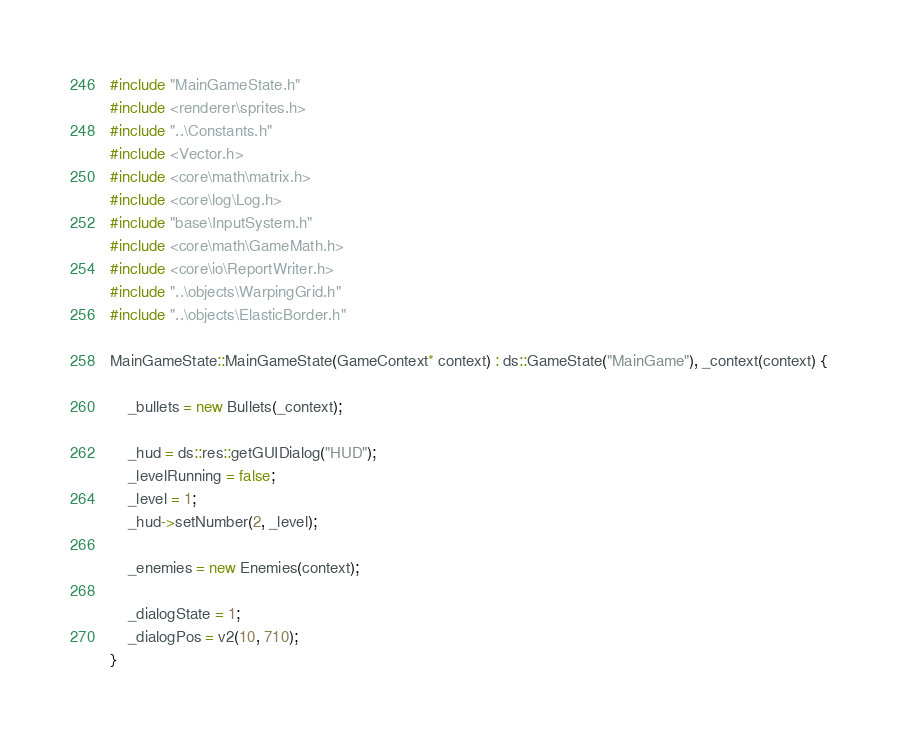<code> <loc_0><loc_0><loc_500><loc_500><_C++_>#include "MainGameState.h"
#include <renderer\sprites.h>
#include "..\Constants.h"
#include <Vector.h>
#include <core\math\matrix.h>
#include <core\log\Log.h>
#include "base\InputSystem.h"
#include <core\math\GameMath.h>
#include <core\io\ReportWriter.h>
#include "..\objects\WarpingGrid.h"
#include "..\objects\ElasticBorder.h"

MainGameState::MainGameState(GameContext* context) : ds::GameState("MainGame"), _context(context) {
	
	_bullets = new Bullets(_context);

	_hud = ds::res::getGUIDialog("HUD");
	_levelRunning = false;
	_level = 1;
	_hud->setNumber(2, _level);

	_enemies = new Enemies(context);

	_dialogState = 1;
	_dialogPos = v2(10, 710);
}

</code> 